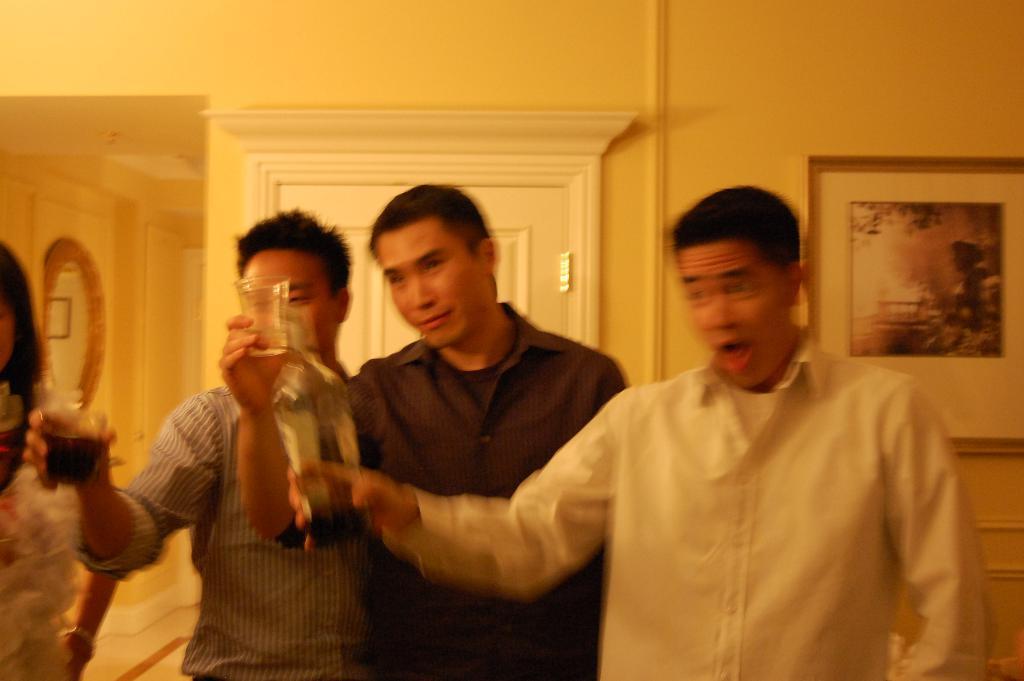Describe this image in one or two sentences. This image is clicked inside a room. There is a mirror on the left side. There is a photo frame on the right side. There is a door in the middle. There are 4 persons standing in the middle. Three of them are holding glasses. 